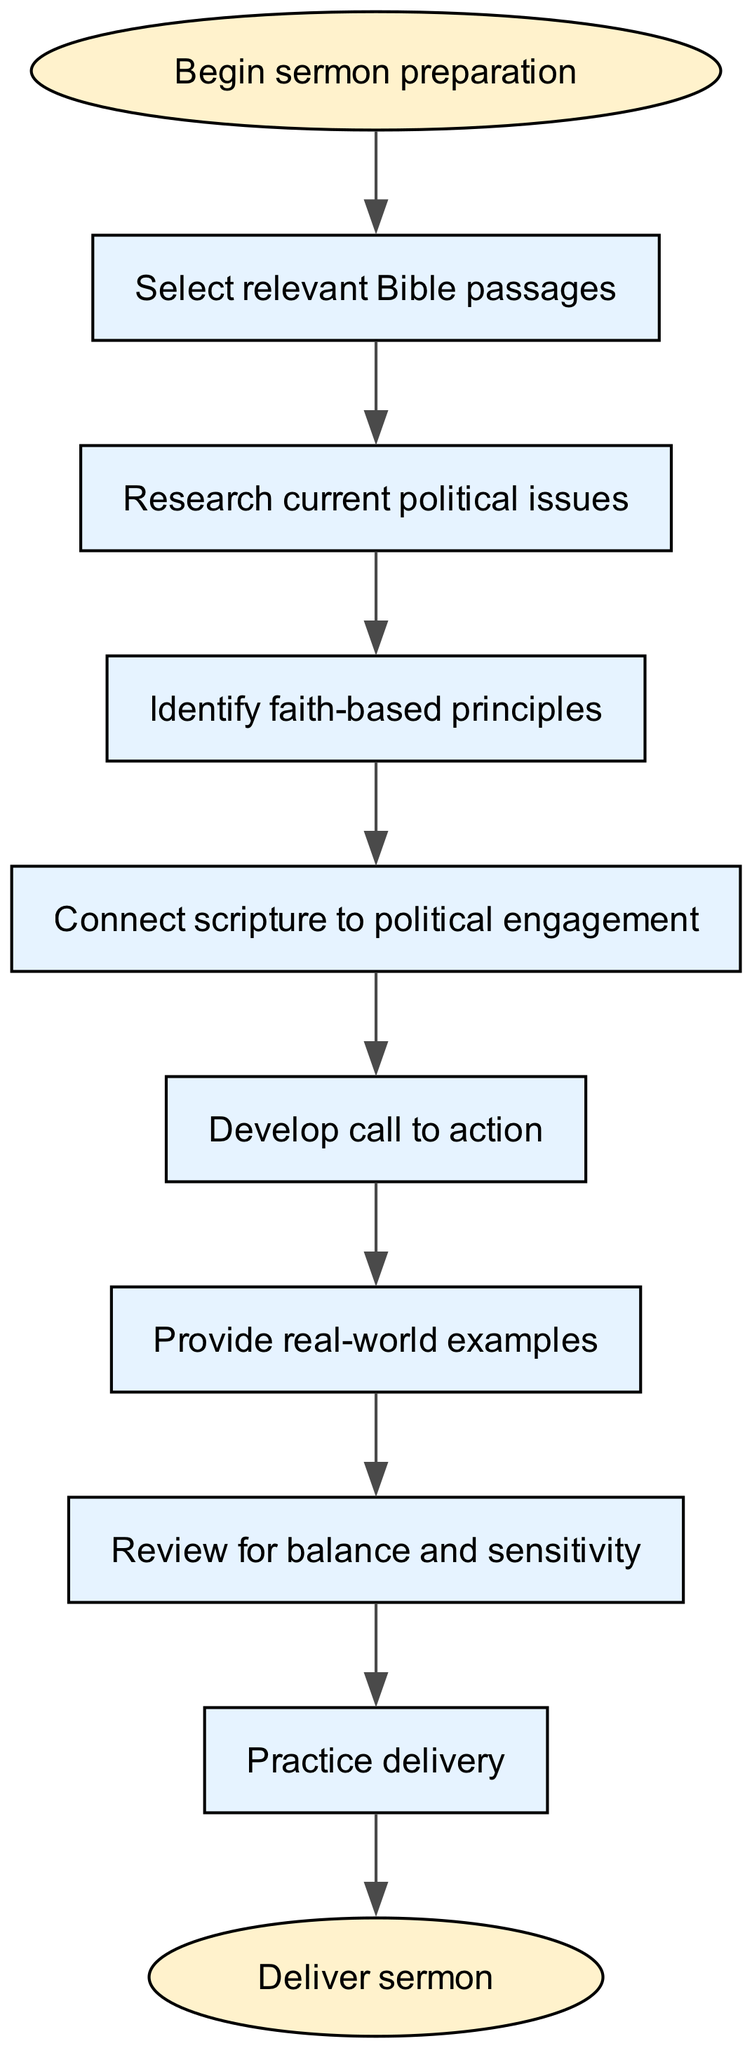What is the first step in sermon preparation? The diagram indicates that the first step in sermon preparation is represented by the node labeled "Begin sermon preparation." This is the starting point of the flow chart.
Answer: Begin sermon preparation How many nodes are present in the diagram? By counting the individual nodes represented in the flow chart, we find there are 10 nodes involved in distinct steps of the sermon preparation process.
Answer: 10 What comes after selecting relevant Bible passages? According to the flow chart, after "Select relevant Bible passages," the next step indicated is "Research current political issues"; this defines the sequential flow of actions.
Answer: Research current political issues Which step connects scripture to political engagement? The flow chart clearly identifies the node "Connect scripture to political engagement" as the step dedicated to linking the selected scripture with the theme of political engagement.
Answer: Connect scripture to political engagement What is the last step in the sermon preparation process? The diagram shows that the final step, represented by the end node, is to "Deliver sermon," which concludes the preparation process outlined in the flow chart.
Answer: Deliver sermon What is the relationship between "Develop call to action" and "Provide real-world examples"? The flow chart indicates a directional flow from "Develop call to action" to "Provide real-world examples," meaning that the task of developing a call to action directly precedes providing supporting examples.
Answer: Develop call to action → Provide real-world examples What is necessary to review before practice? The flow chart illustrates that the node "Review for balance and sensitivity" must be completed before moving on to "Practice delivery," indicating the need for a review step prior to practicing the sermon.
Answer: Review for balance and sensitivity How does the diagram ensure a logical flow in sermon preparation? The diagram is structured sequentially, where each step logically leads to the next. For instance, "Research current political issues" naturally follows after "Select relevant Bible passages," which ensures that the preparation process is coherent and progressive.
Answer: By sequential connections What feedback mechanism is implied between "Review for balance and sensitivity" and "Practice delivery"? The flow chart suggests that the review step acts as a filtering mechanism that ensures the sermon is balanced and sensitive before it is practiced, reinforcing the importance of thoughtful preparation in delivering the sermon.
Answer: Review leads to practice 